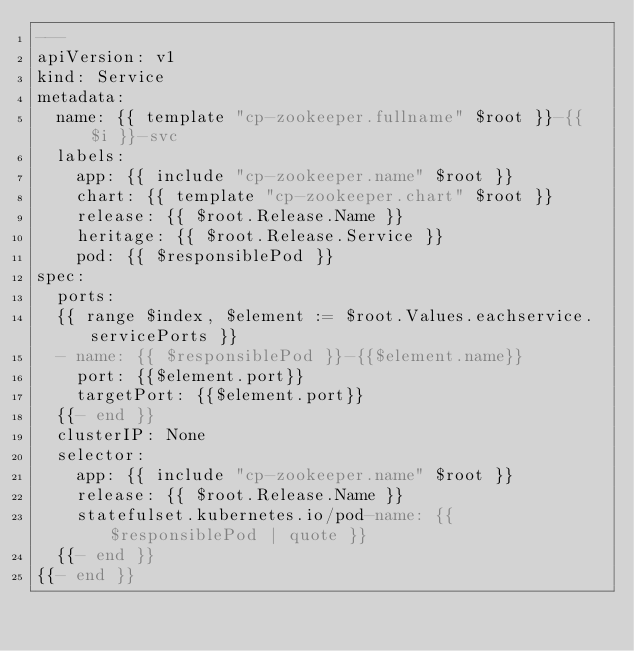<code> <loc_0><loc_0><loc_500><loc_500><_YAML_>---
apiVersion: v1
kind: Service
metadata:
  name: {{ template "cp-zookeeper.fullname" $root }}-{{ $i }}-svc
  labels:
    app: {{ include "cp-zookeeper.name" $root }}
    chart: {{ template "cp-zookeeper.chart" $root }}
    release: {{ $root.Release.Name }}
    heritage: {{ $root.Release.Service }}
    pod: {{ $responsiblePod }}
spec:
  ports:
  {{ range $index, $element := $root.Values.eachservice.servicePorts }}
  - name: {{ $responsiblePod }}-{{$element.name}}
    port: {{$element.port}}
    targetPort: {{$element.port}}
  {{- end }}
  clusterIP: None
  selector:
    app: {{ include "cp-zookeeper.name" $root }}
    release: {{ $root.Release.Name }}
    statefulset.kubernetes.io/pod-name: {{ $responsiblePod | quote }}
  {{- end }}
{{- end }}
</code> 